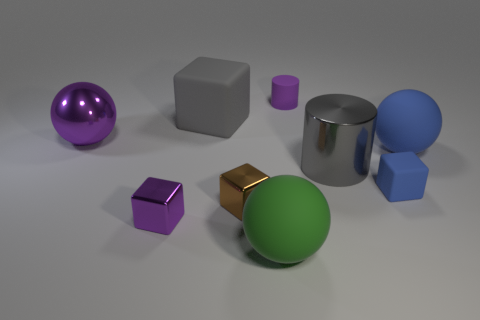Which object in the image is the largest and what geometric shape is it? The largest object in the image is the silver metallic thing in the center, which is a cylinder. You can tell by its circular base and the way its sides curve up to a second circular surface parallel to the first. Is there a pattern to the arrangement of the objects? The objects are arranged somewhat randomly, but they all rest on the same flat surface, suggesting an orderly display. There is no discernible pattern, such as from smallest to largest or by color, but the arrangement provides a clear view of each object's shape and material. 